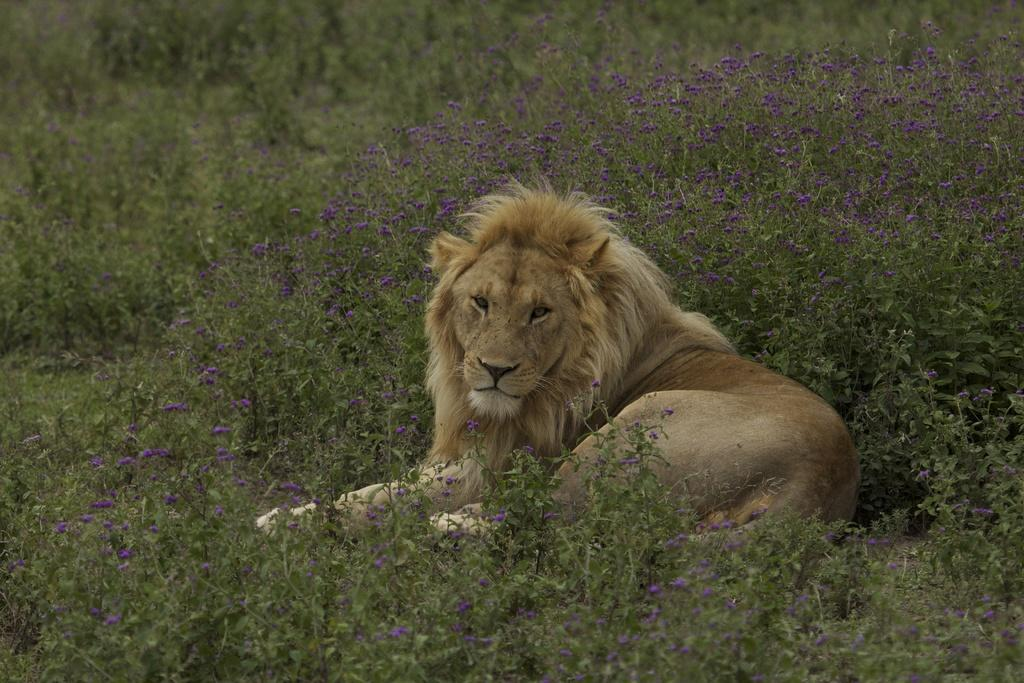What animal is the main subject of the picture? There is a lion in the picture. What is the color of the lion? The lion is brown in color. What else can be seen in the picture besides the lion? There are plants visible in the picture. What type of mist can be seen surrounding the lion in the image? There is no mist present in the image; it features a lion and plants. What kind of loaf is the lion holding in the image? The lion is not holding any loaf in the image. 